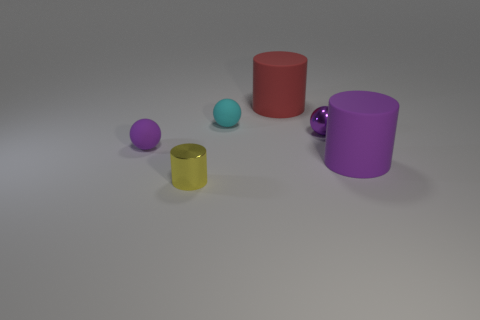Subtract all rubber spheres. How many spheres are left? 1 Subtract all purple balls. How many balls are left? 1 Add 2 cylinders. How many objects exist? 8 Subtract 1 spheres. How many spheres are left? 2 Subtract all gray cylinders. Subtract all green spheres. How many cylinders are left? 3 Subtract all purple balls. How many red cylinders are left? 1 Subtract all spheres. Subtract all big purple things. How many objects are left? 2 Add 1 rubber objects. How many rubber objects are left? 5 Add 3 tiny purple metal balls. How many tiny purple metal balls exist? 4 Subtract 0 brown blocks. How many objects are left? 6 